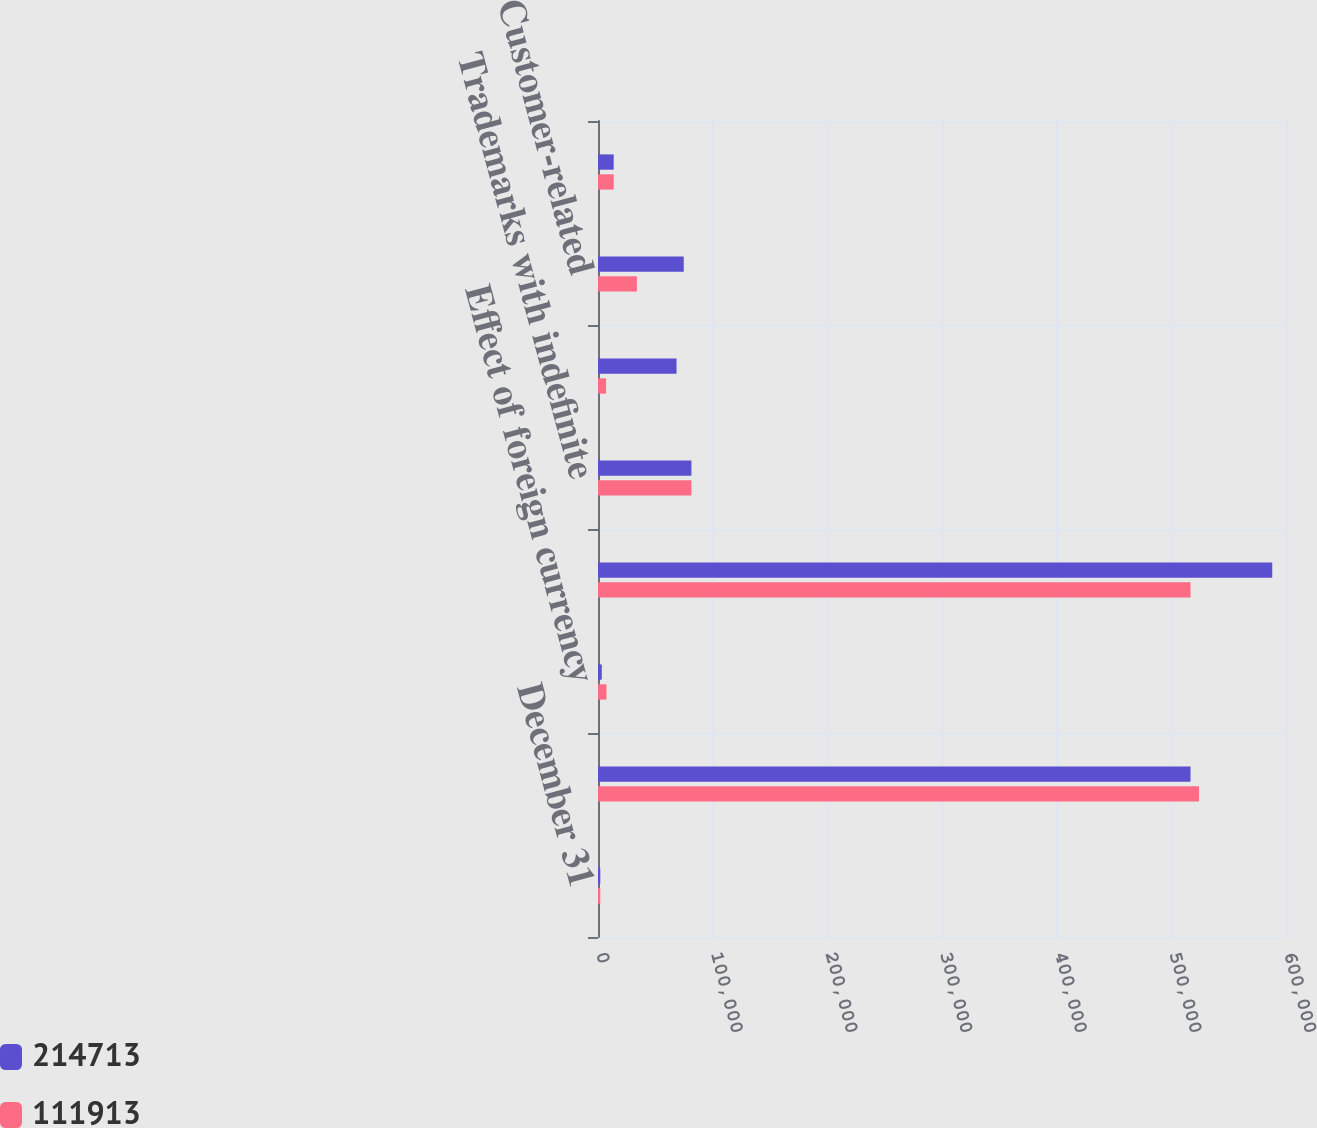Convert chart. <chart><loc_0><loc_0><loc_500><loc_500><stacked_bar_chart><ecel><fcel>December 31<fcel>Goodwill balance at beginning<fcel>Effect of foreign currency<fcel>Goodwill balance at end of<fcel>Trademarks with indefinite<fcel>Trademarks<fcel>Customer-related<fcel>Intangible asset associated<nl><fcel>214713<fcel>2012<fcel>516745<fcel>3284<fcel>588003<fcel>81465<fcel>68490<fcel>74790<fcel>13683<nl><fcel>111913<fcel>2011<fcel>524134<fcel>7389<fcel>516745<fcel>81465<fcel>7048<fcel>33926<fcel>13683<nl></chart> 